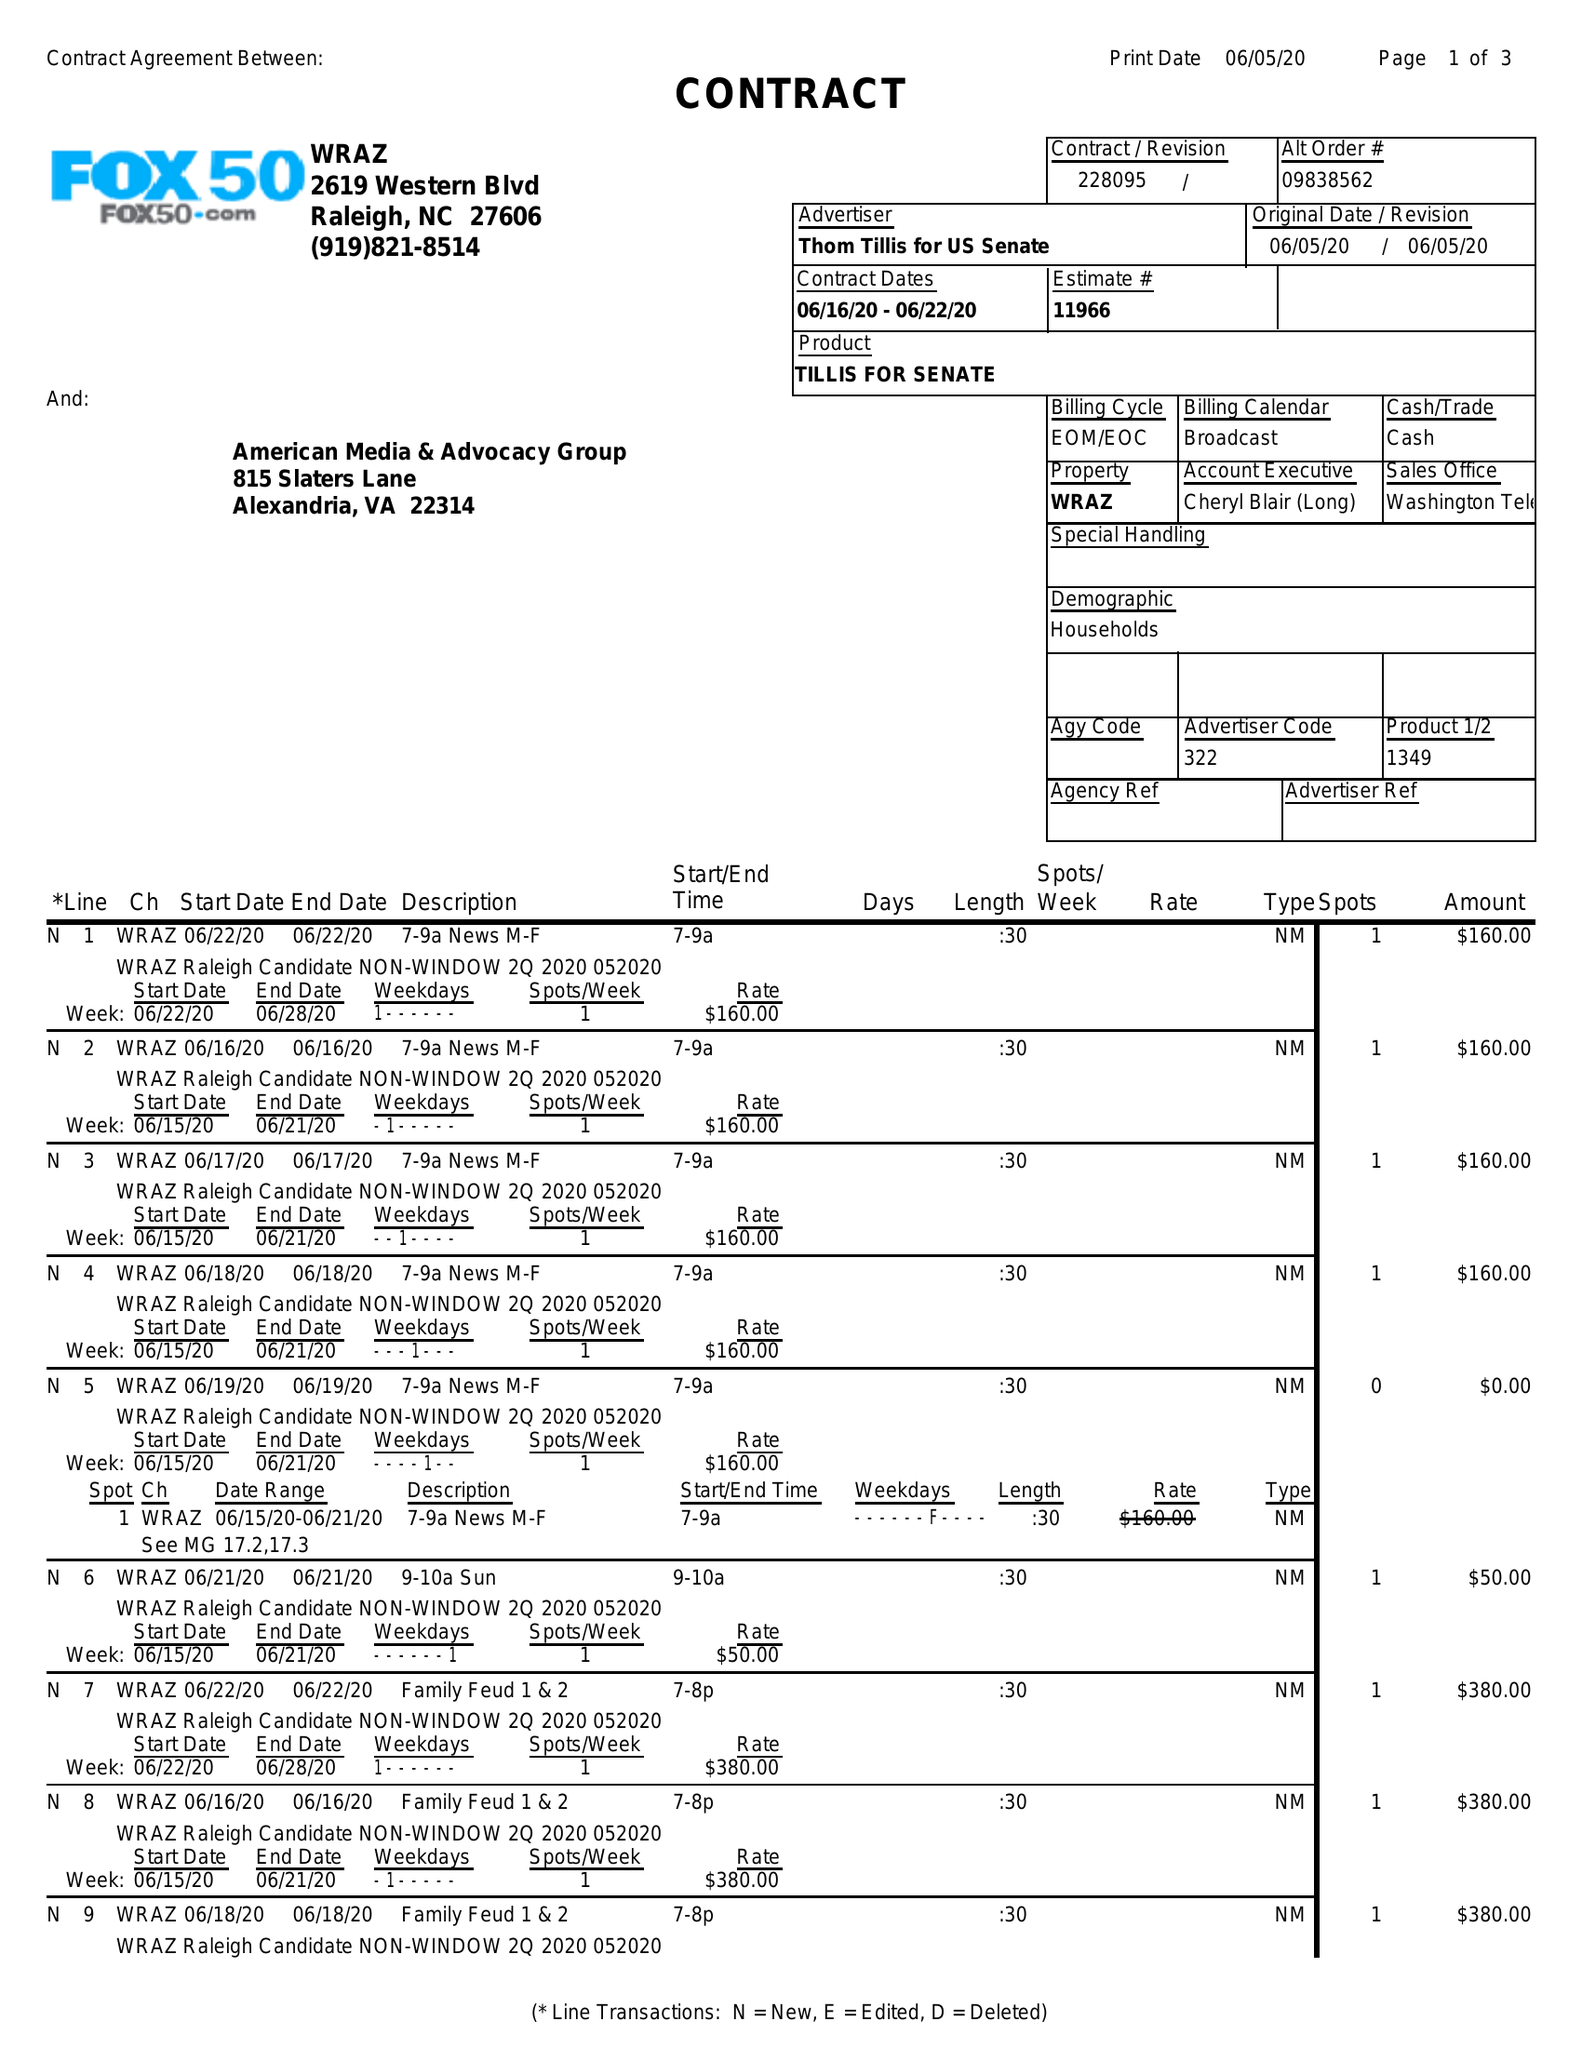What is the value for the advertiser?
Answer the question using a single word or phrase. THOM TILLIS FOR US SENATE 